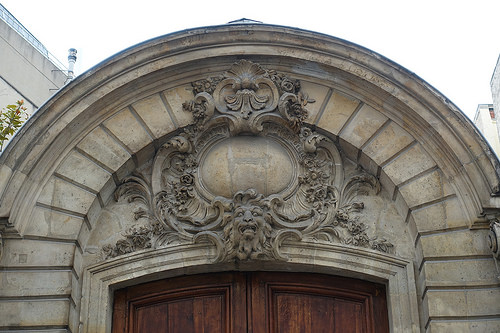<image>
Is there a statue above the door? Yes. The statue is positioned above the door in the vertical space, higher up in the scene. 